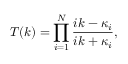Convert formula to latex. <formula><loc_0><loc_0><loc_500><loc_500>T ( k ) = \prod _ { i = 1 } ^ { N } { \frac { i k - \kappa _ { i } } { i k + \kappa _ { i } } } ,</formula> 